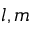Convert formula to latex. <formula><loc_0><loc_0><loc_500><loc_500>l , m</formula> 